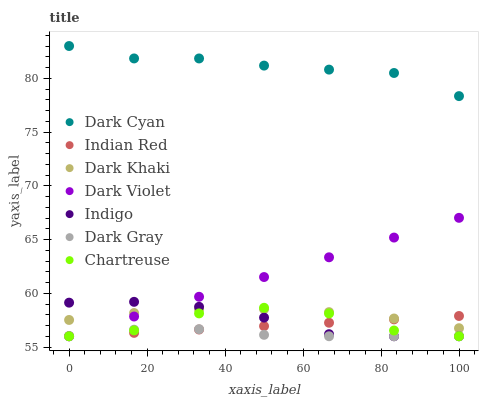Does Dark Gray have the minimum area under the curve?
Answer yes or no. Yes. Does Dark Cyan have the maximum area under the curve?
Answer yes or no. Yes. Does Indigo have the minimum area under the curve?
Answer yes or no. No. Does Indigo have the maximum area under the curve?
Answer yes or no. No. Is Dark Violet the smoothest?
Answer yes or no. Yes. Is Chartreuse the roughest?
Answer yes or no. Yes. Is Indigo the smoothest?
Answer yes or no. No. Is Indigo the roughest?
Answer yes or no. No. Does Dark Gray have the lowest value?
Answer yes or no. Yes. Does Dark Khaki have the lowest value?
Answer yes or no. No. Does Dark Cyan have the highest value?
Answer yes or no. Yes. Does Indigo have the highest value?
Answer yes or no. No. Is Dark Khaki less than Dark Cyan?
Answer yes or no. Yes. Is Dark Cyan greater than Dark Gray?
Answer yes or no. Yes. Does Chartreuse intersect Dark Violet?
Answer yes or no. Yes. Is Chartreuse less than Dark Violet?
Answer yes or no. No. Is Chartreuse greater than Dark Violet?
Answer yes or no. No. Does Dark Khaki intersect Dark Cyan?
Answer yes or no. No. 